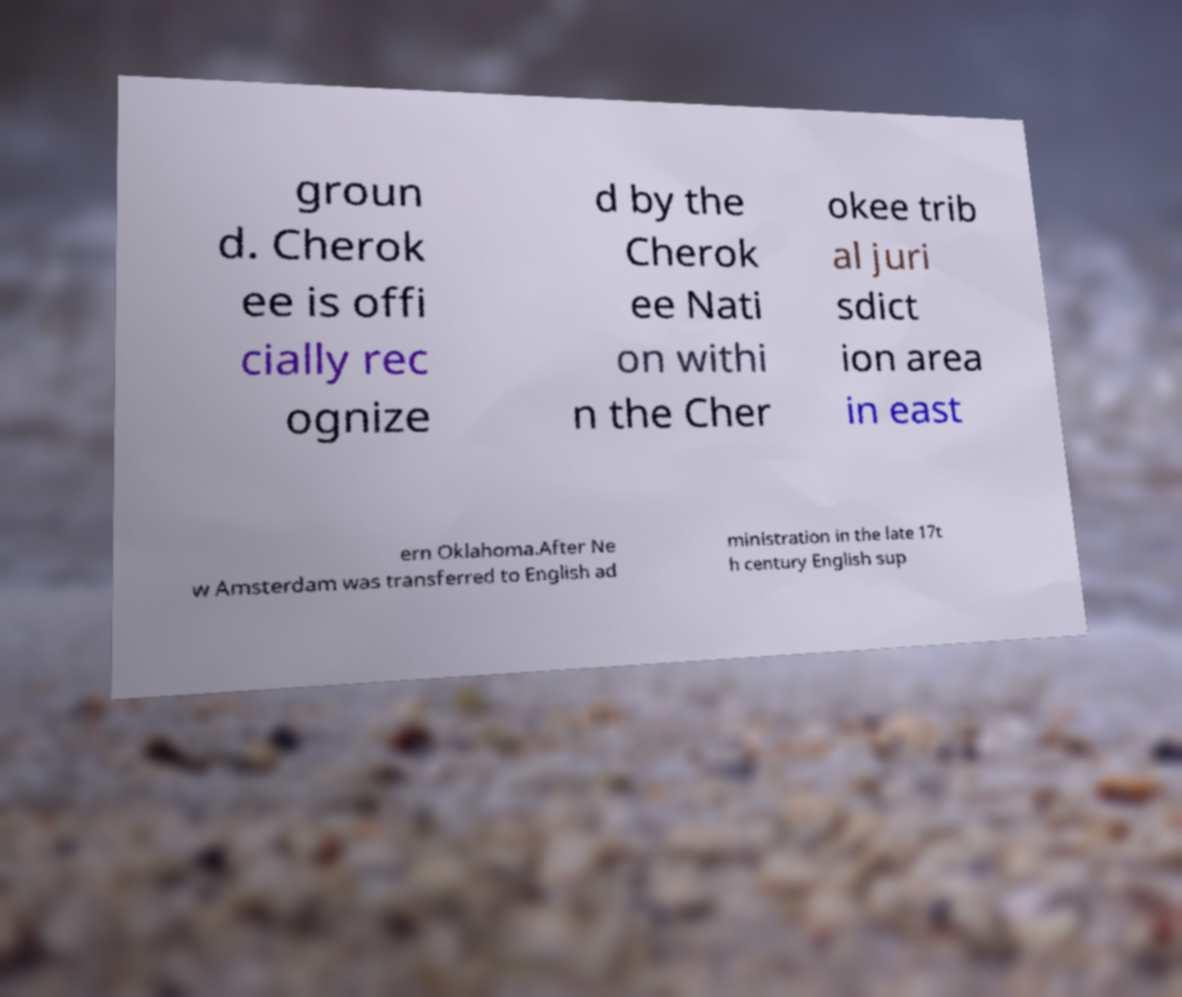For documentation purposes, I need the text within this image transcribed. Could you provide that? groun d. Cherok ee is offi cially rec ognize d by the Cherok ee Nati on withi n the Cher okee trib al juri sdict ion area in east ern Oklahoma.After Ne w Amsterdam was transferred to English ad ministration in the late 17t h century English sup 